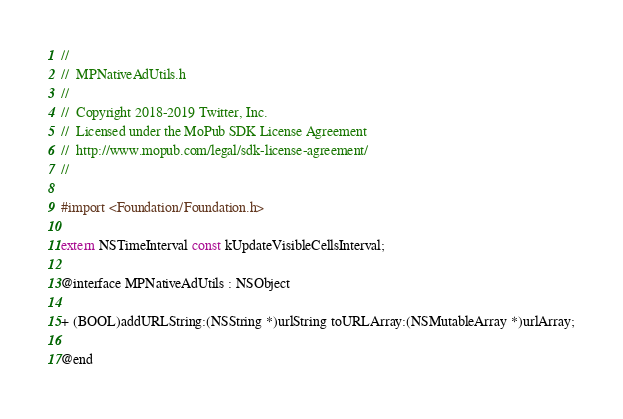<code> <loc_0><loc_0><loc_500><loc_500><_C_>//
//  MPNativeAdUtils.h
//
//  Copyright 2018-2019 Twitter, Inc.
//  Licensed under the MoPub SDK License Agreement
//  http://www.mopub.com/legal/sdk-license-agreement/
//

#import <Foundation/Foundation.h>

extern NSTimeInterval const kUpdateVisibleCellsInterval;

@interface MPNativeAdUtils : NSObject

+ (BOOL)addURLString:(NSString *)urlString toURLArray:(NSMutableArray *)urlArray;

@end
</code> 